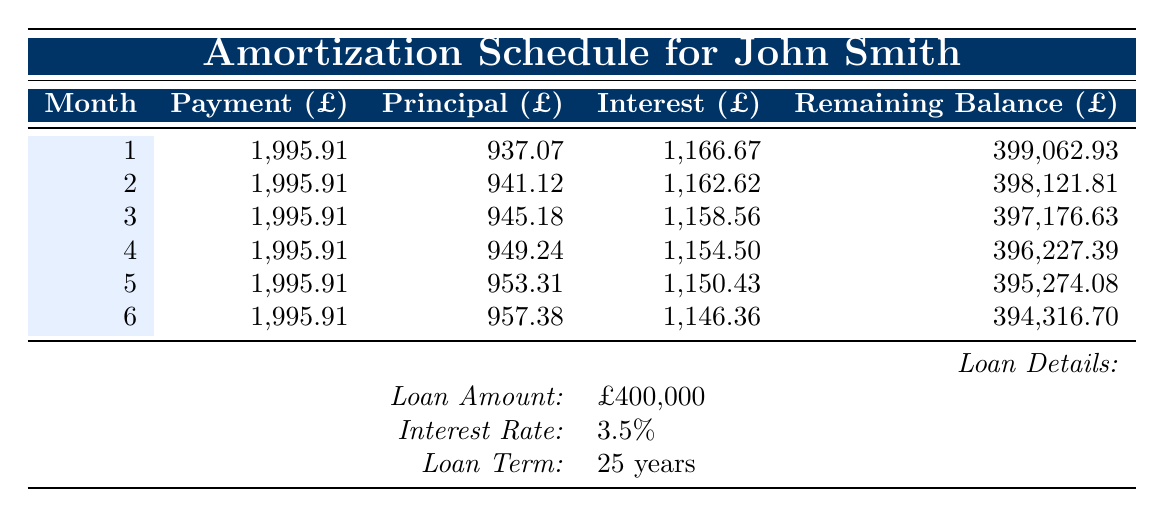What is the monthly payment for John Smith's loan? The table indicates that the monthly payment for John Smith's loan is consistently listed as £1,995.91 across all six months.
Answer: £1,995.91 How much principal is paid off in the first month? According to the table, the principal paid off in the first month is specified as £937.07.
Answer: £937.07 What is the total interest paid in the first three months? To find the total interest paid in the first three months, sum the interest amounts for each month: £1,166.67 (month 1) + £1,162.62 (month 2) + £1,158.56 (month 3) = £3,487.85.
Answer: £3,487.85 Is the interest payment decreasing over the first six months? Examining the interest amounts shows they decrease every month: £1,166.67 (month 1), £1,162.62 (month 2), £1,158.56 (month 3), £1,154.50 (month 4), £1,150.43 (month 5), £1,146.36 (month 6). Since all values are lower than the previous month, the statement is true.
Answer: Yes What is the remaining balance after the sixth month? The remaining balance after the sixth month is provided in the table as £394,316.70.
Answer: £394,316.70 How much principal has been paid off by the end of the fifth month? To find the total principal paid off by the end of the fifth month, add the principal amounts from the first five months: £937.07 + £941.12 + £945.18 + £949.24 + £953.31 = £4,726.92.
Answer: £4,726.92 What is the difference between the interest payment in the first month and that in the second month? The interest payment in the first month is £1,166.67 and in the second month is £1,162.62. The difference between them is £1,166.67 - £1,162.62 = £4.05.
Answer: £4.05 What is the average monthly principal payment for the first six months? The principal payments for the first six months are: £937.07, £941.12, £945.18, £949.24, £953.31, and £957.38. Summing these values gives £5,724.30. Dividing by 6 provides the average of £5,724.30 / 6 = £954.05.
Answer: £954.05 